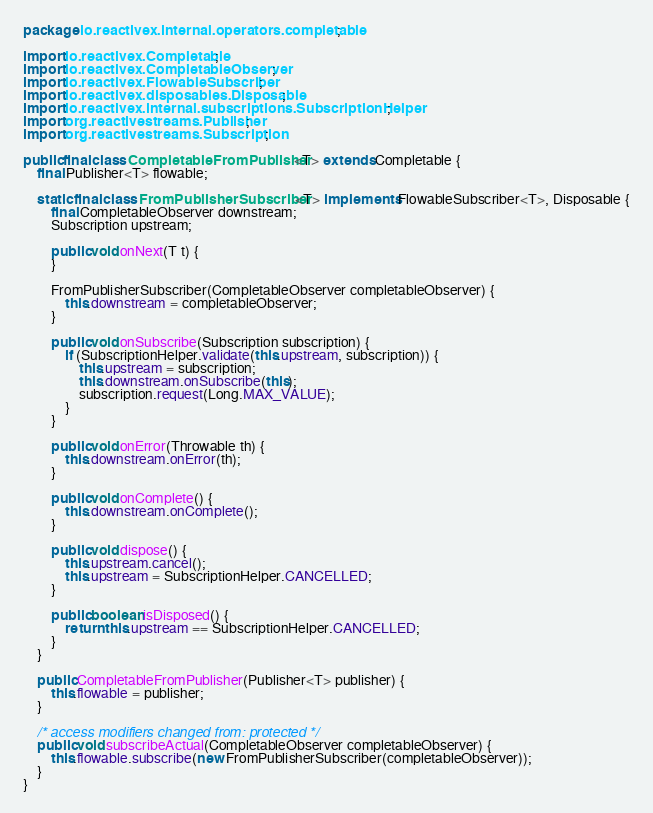Convert code to text. <code><loc_0><loc_0><loc_500><loc_500><_Java_>package io.reactivex.internal.operators.completable;

import io.reactivex.Completable;
import io.reactivex.CompletableObserver;
import io.reactivex.FlowableSubscriber;
import io.reactivex.disposables.Disposable;
import io.reactivex.internal.subscriptions.SubscriptionHelper;
import org.reactivestreams.Publisher;
import org.reactivestreams.Subscription;

public final class CompletableFromPublisher<T> extends Completable {
    final Publisher<T> flowable;

    static final class FromPublisherSubscriber<T> implements FlowableSubscriber<T>, Disposable {
        final CompletableObserver downstream;
        Subscription upstream;

        public void onNext(T t) {
        }

        FromPublisherSubscriber(CompletableObserver completableObserver) {
            this.downstream = completableObserver;
        }

        public void onSubscribe(Subscription subscription) {
            if (SubscriptionHelper.validate(this.upstream, subscription)) {
                this.upstream = subscription;
                this.downstream.onSubscribe(this);
                subscription.request(Long.MAX_VALUE);
            }
        }

        public void onError(Throwable th) {
            this.downstream.onError(th);
        }

        public void onComplete() {
            this.downstream.onComplete();
        }

        public void dispose() {
            this.upstream.cancel();
            this.upstream = SubscriptionHelper.CANCELLED;
        }

        public boolean isDisposed() {
            return this.upstream == SubscriptionHelper.CANCELLED;
        }
    }

    public CompletableFromPublisher(Publisher<T> publisher) {
        this.flowable = publisher;
    }

    /* access modifiers changed from: protected */
    public void subscribeActual(CompletableObserver completableObserver) {
        this.flowable.subscribe(new FromPublisherSubscriber(completableObserver));
    }
}
</code> 